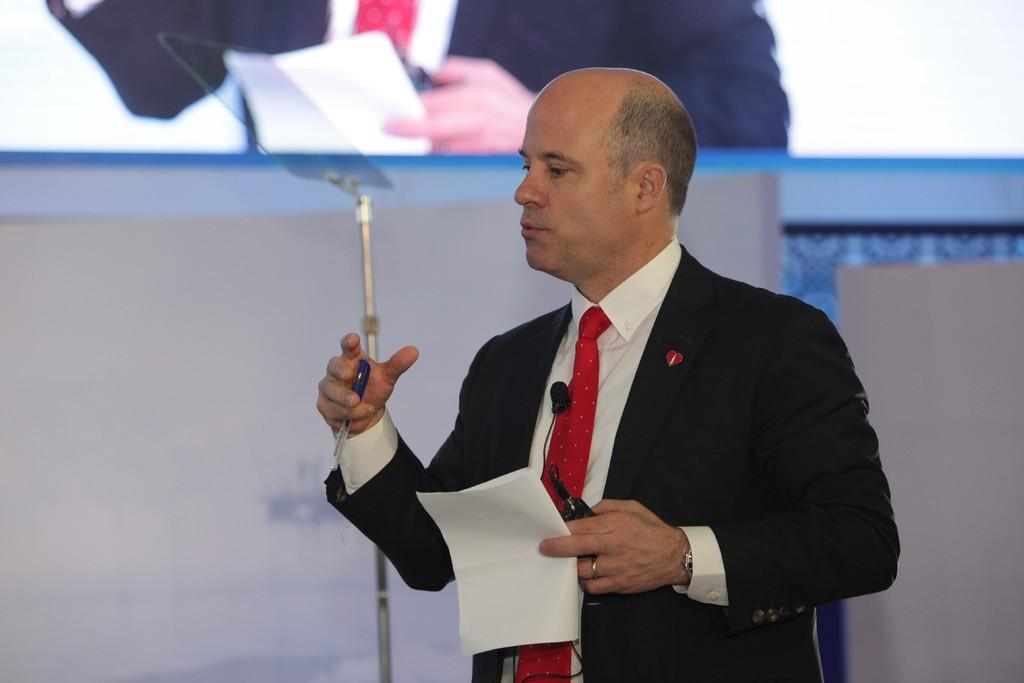Who is present in the image? There is a man in the image. What is the man holding in his hand? The man is holding a paper and a pen. What can be seen on the screen in the image? The facts provided do not mention any details about the screen, so we cannot answer this question definitively. How many eggs are on the table in the image? There is no table or eggs present in the image. What type of vase is on the shelf in the image? There is no vase or shelf present in the image. 